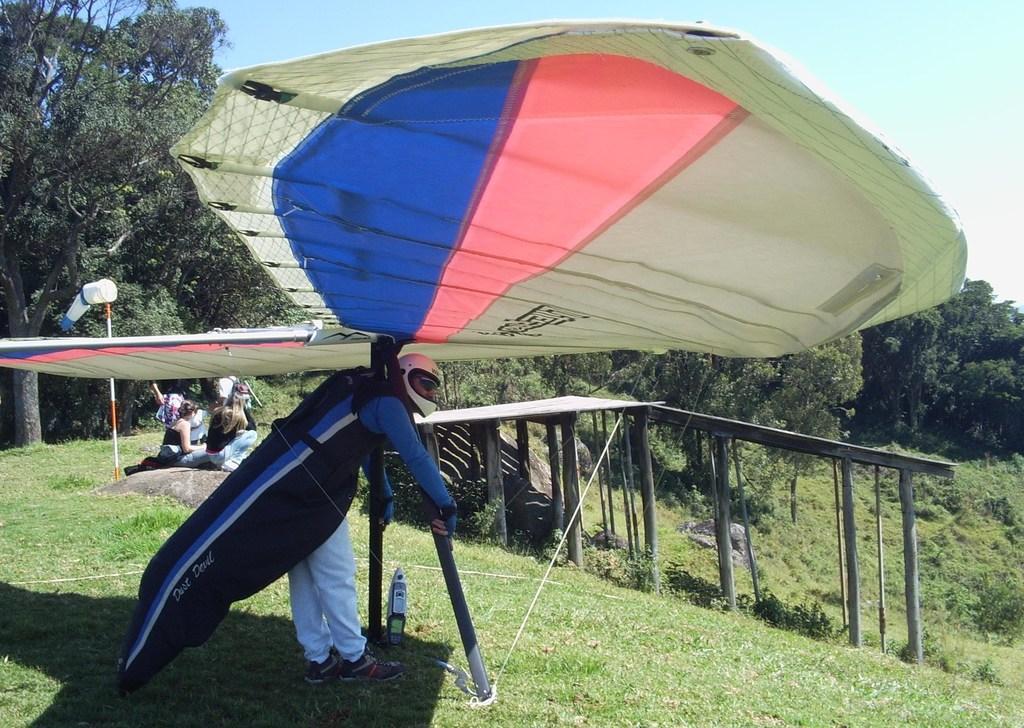Please provide a concise description of this image. In this picture we can see a man wore a helmet and standing on the ground, wooden poles, trees and some people sitting on rock and in the background we can see the sky. 